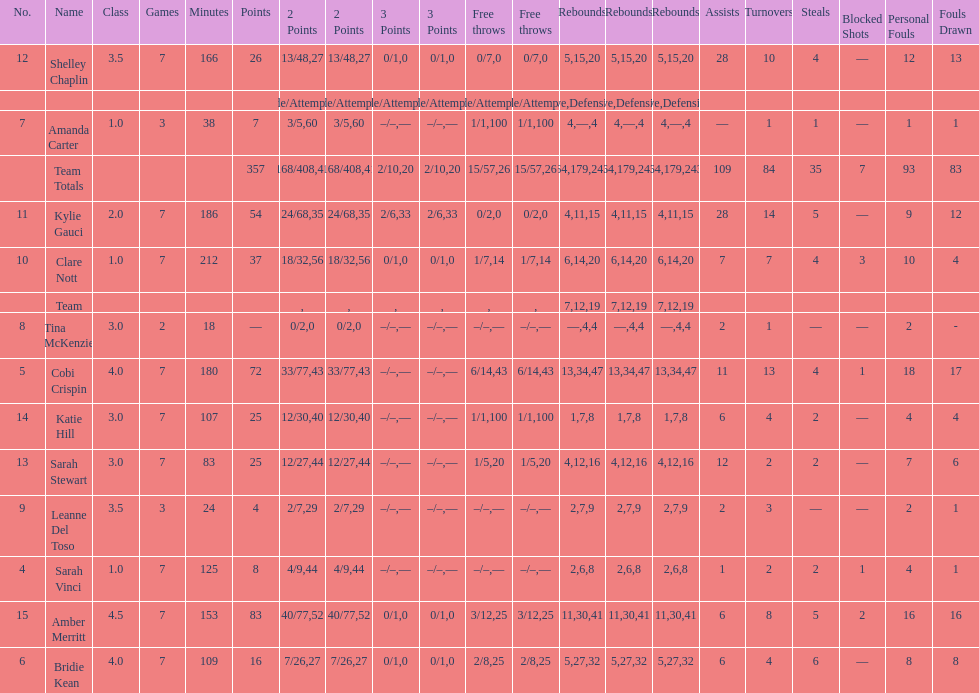Who is the first person on the list to play less than 20 minutes? Tina McKenzie. 